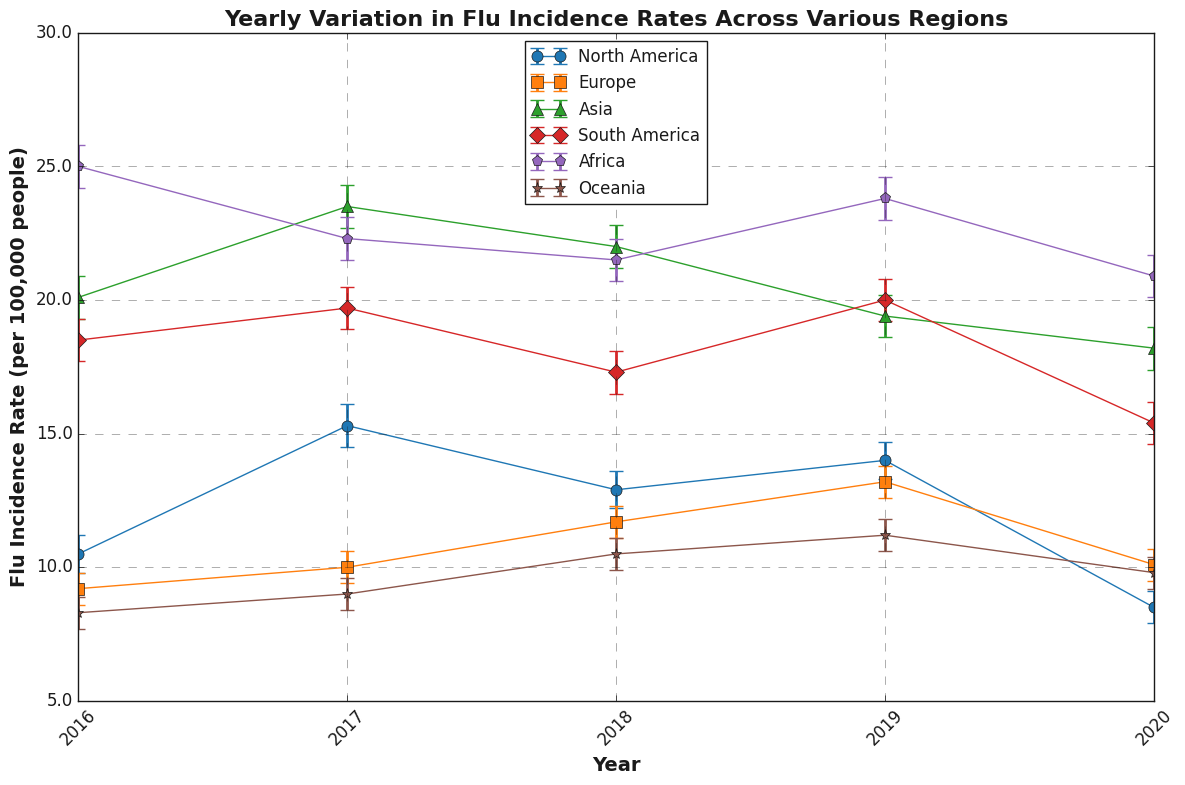What's the average flu incidence rate for North America over the 5 years? To find the average, add up all the yearly flu incidence rates for North America and divide by the number of years. The rates are 10.5 (2016), 15.3 (2017), 12.9 (2018), 14.0 (2019), and 8.5 (2020). Sum: 10.5 + 15.3 + 12.9 + 14.0 + 8.5 = 61.2. Number of years = 5. Average = 61.2 / 5 = 12.24
Answer: 12.24 Which region had the highest flu incidence rate in 2016? Look at the flu incidence rates for all regions in 2016. The rates are: North America (10.5), Europe (9.2), Asia (20.1), South America (18.5), Africa (25.0), and Oceania (8.3). The highest value is 25.0 for Africa.
Answer: Africa In which year did Asia experience the largest decrease in flu incidence rate compared to the previous year? Compare the flu incidence rates for Asia from one year to the next to find the largest decrease. The rates are: 2016 (20.1), 2017 (23.5), 2018 (22.0), 2019 (19.4), 2020 (18.2). The decreases are: 2017-2016 = 3.4, 2018-2017 = -1.5, 2019-2018 = -2.6, 2020-2019 = -1.2. The largest decrease, -2.6, is between 2018 and 2019.
Answer: 2019 How did Oceania’s flu incidence rate change from 2018 to 2019? Look at the flu incidence rates for Oceania in 2018 and 2019. The rates are 10.5 in 2018 and 11.2 in 2019. Calculate the change: 11.2 - 10.5 = 0.7. Oceania’s rate increased by 0.7.
Answer: Increased by 0.7 Identify the region that has the smallest confidence interval range in 2020. Calculate the confidence interval range for all regions in 2020. North America: 9.1 - 7.9 = 1.2, Europe: 10.7 - 9.5 = 1.2, Asia: 19.0 - 17.4 = 1.6, South America: 16.2 - 14.6 = 1.6, Africa: 21.7 - 20.1 = 1.6, Oceania: 10.4 - 9.2 = 1.2. Three regions have the smallest range of 1.2: North America, Europe, and Oceania.
Answer: North America, Europe, and Oceania Which region's flu incidence rate remained relatively stable across the years, judging by the error bars? Examine the error bars for each region. Error bars show the variability; regions with smaller and consistent error bars indicate stability. Oceania has small error bars and small changes across the years, indicating it remained relatively stable.
Answer: Oceania In 2020, did North America's upper confidence interval exceed 9.5? Look at North America's 2020 flu incidence rate and its upper confidence interval. The interval for North America in 2020 is from 7.9 to 9.1. The upper confidence interval is 9.1, which does not exceed 9.5.
Answer: No How does Africa's flu incidence rate in 2017 compare to its rate in 2020? Look at the flu incidence rates for Africa in 2017 and 2020. The rates are 22.3 in 2017 and 20.9 in 2020. Africa’s rate decreased from 2017 to 2020.
Answer: Decreased Which region has the most variation in flu incidence rate between 2016 and 2020? Calculate the range (difference between the highest and lowest rates) for each region from 2016 to 2020. North America: 15.3 - 8.5 = 6.8, Europe: 13.2 - 9.2 = 4.0, Asia: 23.5 - 18.2 = 5.3, South America: 20.0 - 15.4 = 4.6, Africa: 25.0 - 20.9 = 4.1, Oceania: 11.2 - 8.3 = 2.9. North America has the most variation.
Answer: North America 